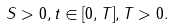Convert formula to latex. <formula><loc_0><loc_0><loc_500><loc_500>S > 0 , t \in [ 0 , T ] , T > 0 .</formula> 